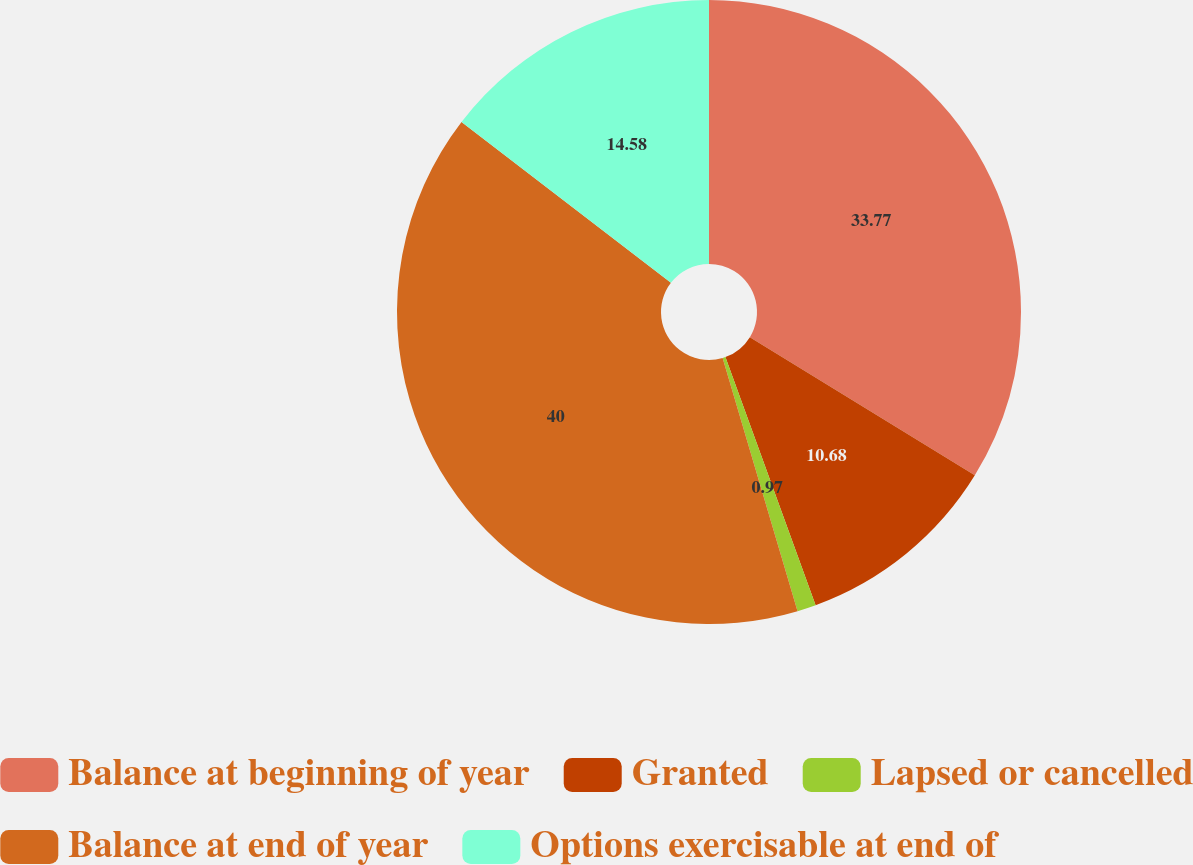<chart> <loc_0><loc_0><loc_500><loc_500><pie_chart><fcel>Balance at beginning of year<fcel>Granted<fcel>Lapsed or cancelled<fcel>Balance at end of year<fcel>Options exercisable at end of<nl><fcel>33.77%<fcel>10.68%<fcel>0.97%<fcel>40.0%<fcel>14.58%<nl></chart> 